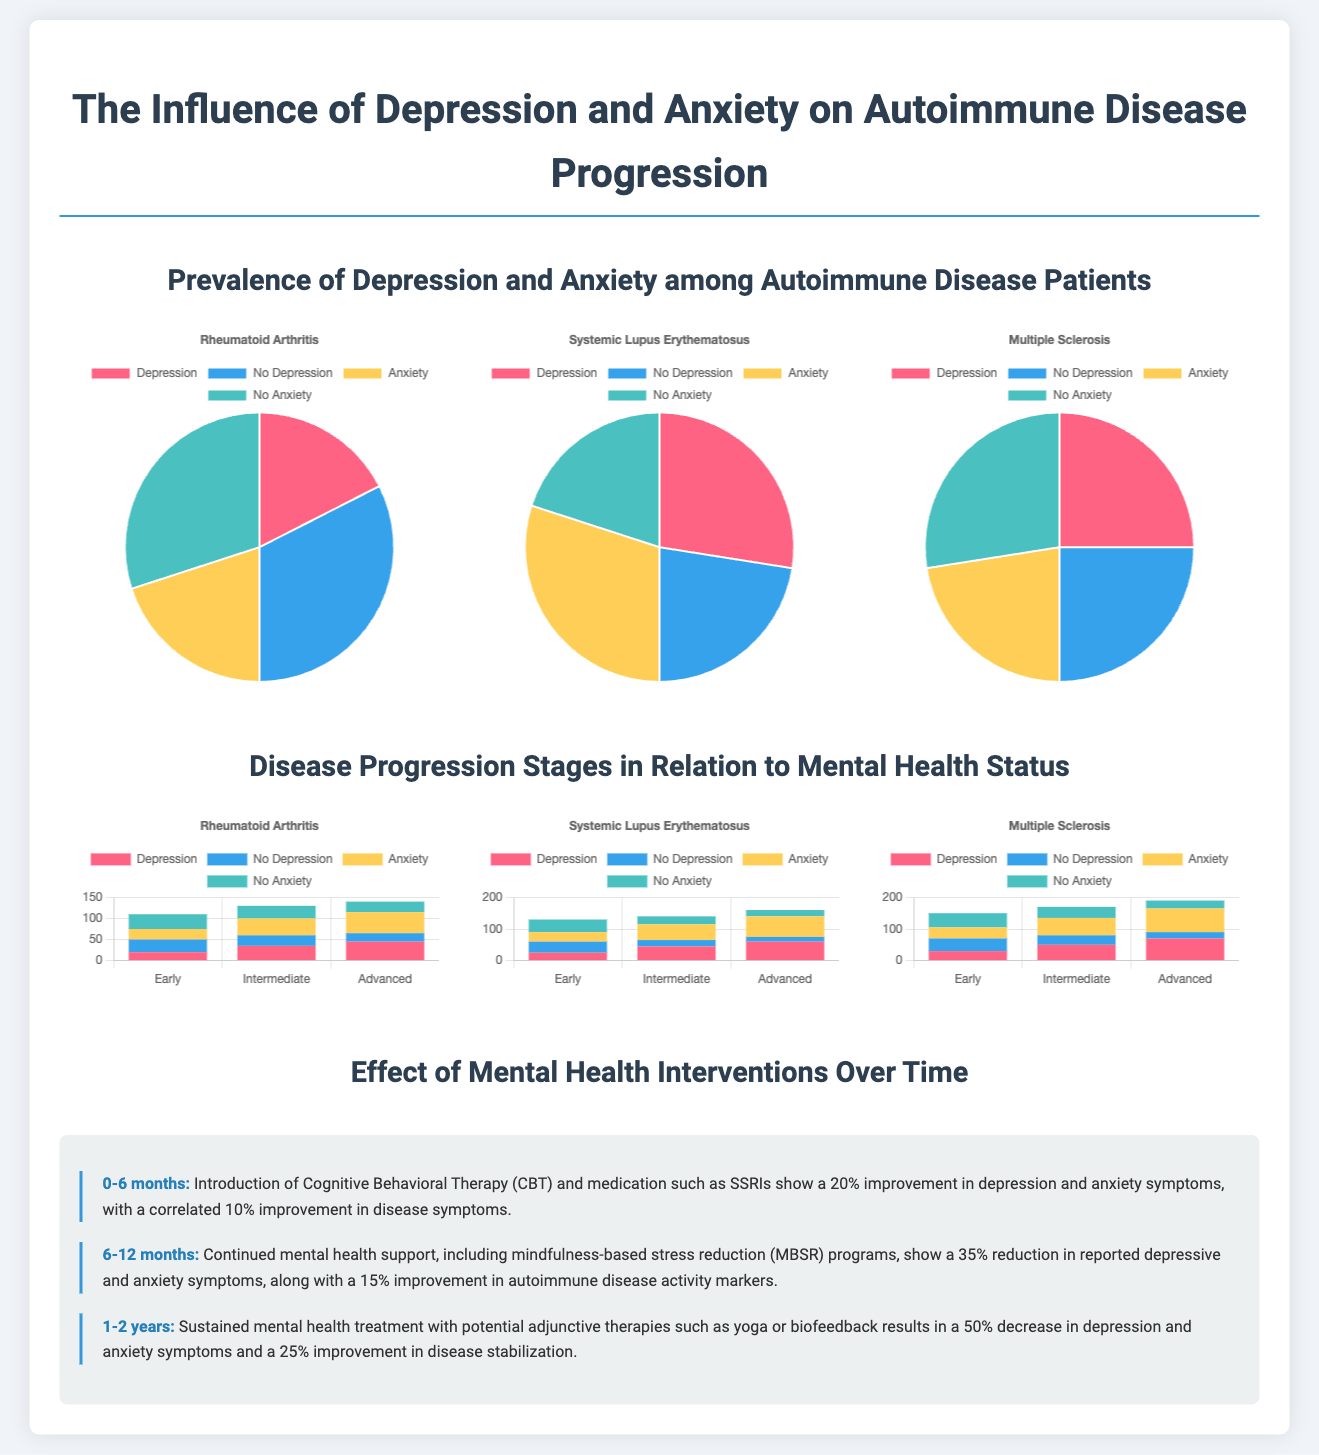What is the percentage of patients with depression in Rheumatoid Arthritis? The pie chart for Rheumatoid Arthritis shows that 35% of patients have depression.
Answer: 35% What is the improvement in disease symptoms after 6-12 months of mental health support? The timeline indicates a 15% improvement in autoimmune disease activity markers after 6-12 months of mental health support.
Answer: 15% What percentage of Multiple Sclerosis patients experience anxiety? The pie chart for Multiple Sclerosis shows that 45% of patients have anxiety.
Answer: 45% What is the title of the second stacked bar chart? The second stacked bar chart is titled 'Systemic Lupus Erythematosus'.
Answer: Systemic Lupus Erythematosus What is the overall improvement in depression and anxiety symptoms after 1-2 years? The timeline highlights a 50% decrease in depression and anxiety symptoms after 1-2 years.
Answer: 50% What is the trend for patients with no anxiety in the advanced stage of Systemic Lupus Erythematosus? The stacked bar chart shows that 20% of patients with no anxiety are in the advanced stage.
Answer: 20% How many stages of disease progression are shown in the document? The document displays three stages of disease progression: Early, Intermediate, and Advanced.
Answer: Three What mental health intervention is introduced in the first 6 months? The introduction of Cognitive Behavioral Therapy (CBT) is mentioned in the first 6 months timeline item.
Answer: Cognitive Behavioral Therapy (CBT) 